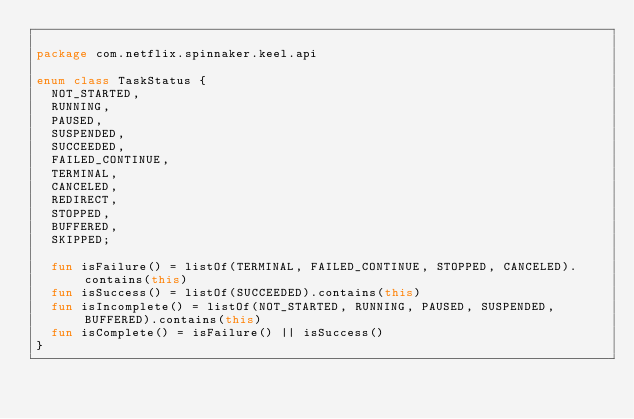Convert code to text. <code><loc_0><loc_0><loc_500><loc_500><_Kotlin_>
package com.netflix.spinnaker.keel.api

enum class TaskStatus {
  NOT_STARTED,
  RUNNING,
  PAUSED,
  SUSPENDED,
  SUCCEEDED,
  FAILED_CONTINUE,
  TERMINAL,
  CANCELED,
  REDIRECT,
  STOPPED,
  BUFFERED,
  SKIPPED;

  fun isFailure() = listOf(TERMINAL, FAILED_CONTINUE, STOPPED, CANCELED).contains(this)
  fun isSuccess() = listOf(SUCCEEDED).contains(this)
  fun isIncomplete() = listOf(NOT_STARTED, RUNNING, PAUSED, SUSPENDED, BUFFERED).contains(this)
  fun isComplete() = isFailure() || isSuccess()
}
</code> 